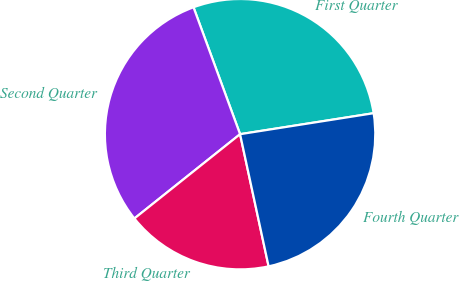Convert chart. <chart><loc_0><loc_0><loc_500><loc_500><pie_chart><fcel>First Quarter<fcel>Second Quarter<fcel>Third Quarter<fcel>Fourth Quarter<nl><fcel>28.12%<fcel>30.12%<fcel>17.67%<fcel>24.1%<nl></chart> 